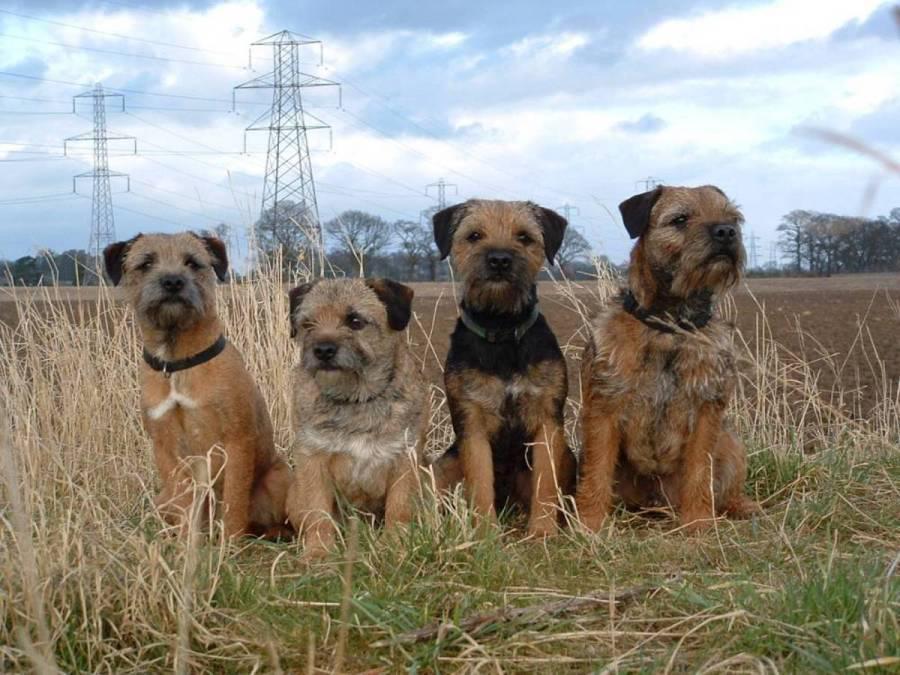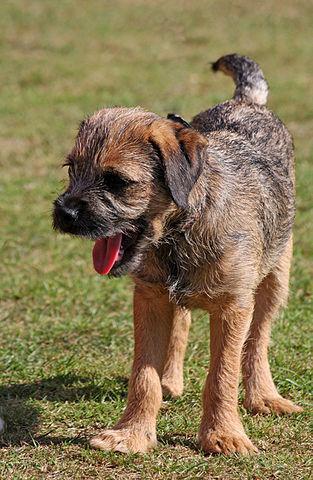The first image is the image on the left, the second image is the image on the right. Considering the images on both sides, is "There are no more than four dogs" valid? Answer yes or no. No. 